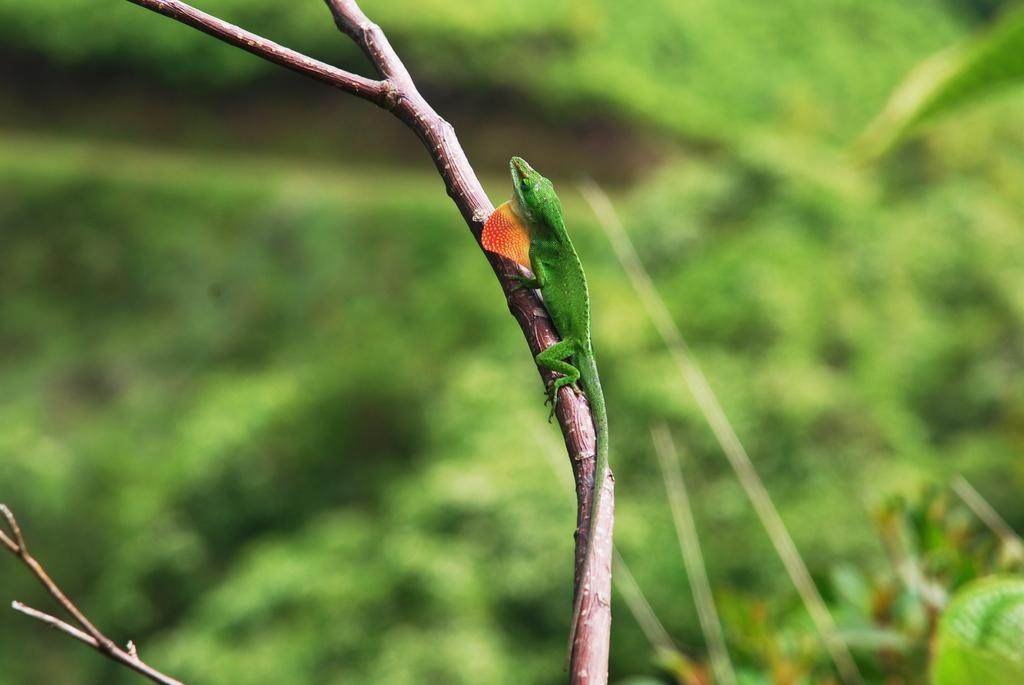What type of animal is in the image? There is a green color reptile in the image. Where is the reptile located? The reptile is on a stem. What color is the background of the image? The background of the image is green. What type of shirt is the giant wearing in the image? There are no giants or shirts present in the image; it features a green reptile on a stem with a green background. 